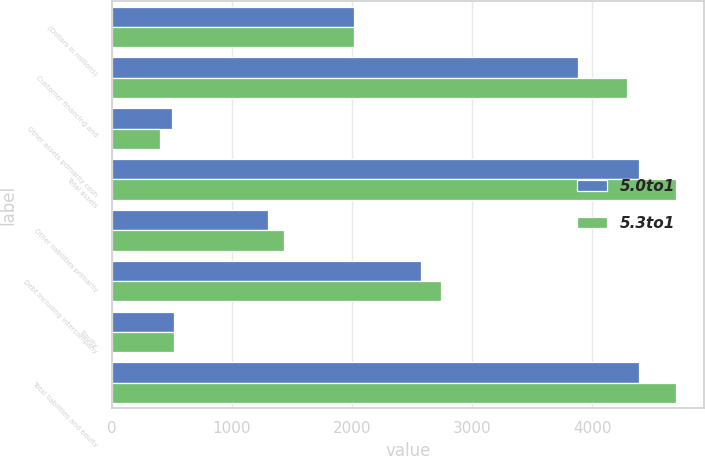<chart> <loc_0><loc_0><loc_500><loc_500><stacked_bar_chart><ecel><fcel>(Dollars in millions)<fcel>Customer financing and<fcel>Other assets primarily cash<fcel>Total assets<fcel>Other liabilities primarily<fcel>Debt including intercompany<fcel>Equity<fcel>Total liabilities and equity<nl><fcel>5.0to1<fcel>2013<fcel>3883<fcel>505<fcel>4388<fcel>1296<fcel>2577<fcel>515<fcel>4388<nl><fcel>5.3to1<fcel>2012<fcel>4290<fcel>402<fcel>4692<fcel>1429<fcel>2742<fcel>521<fcel>4692<nl></chart> 